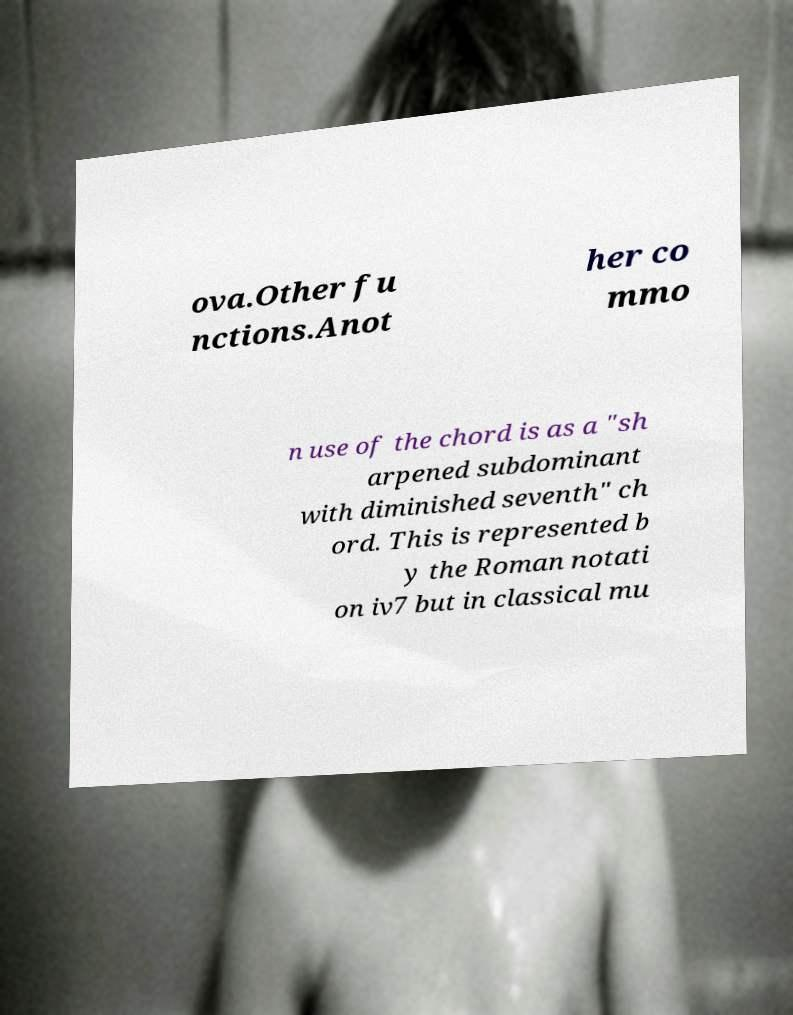There's text embedded in this image that I need extracted. Can you transcribe it verbatim? ova.Other fu nctions.Anot her co mmo n use of the chord is as a "sh arpened subdominant with diminished seventh" ch ord. This is represented b y the Roman notati on iv7 but in classical mu 